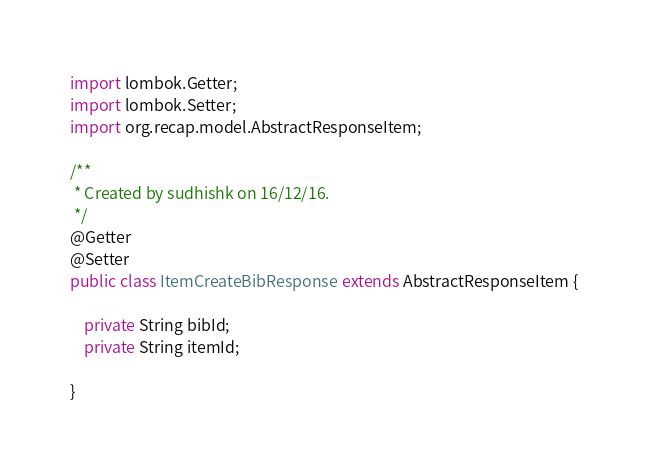<code> <loc_0><loc_0><loc_500><loc_500><_Java_>import lombok.Getter;
import lombok.Setter;
import org.recap.model.AbstractResponseItem;

/**
 * Created by sudhishk on 16/12/16.
 */
@Getter
@Setter
public class ItemCreateBibResponse extends AbstractResponseItem {

    private String bibId;
    private String itemId;

}
</code> 